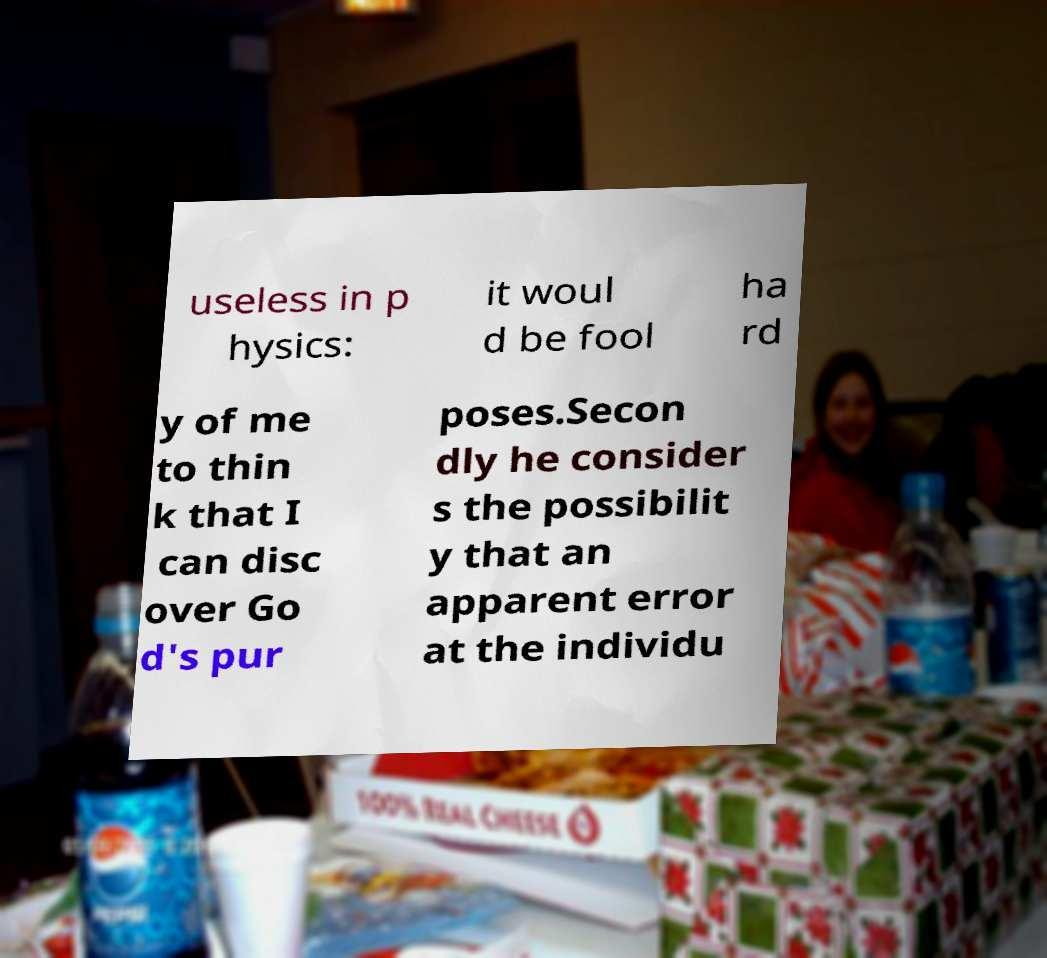Please identify and transcribe the text found in this image. useless in p hysics: it woul d be fool ha rd y of me to thin k that I can disc over Go d's pur poses.Secon dly he consider s the possibilit y that an apparent error at the individu 